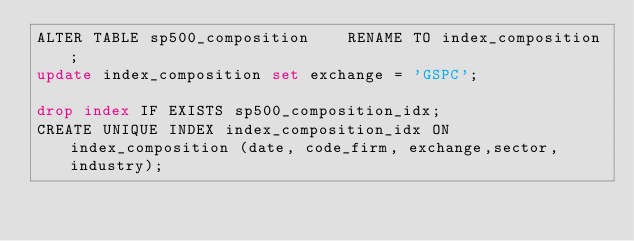<code> <loc_0><loc_0><loc_500><loc_500><_SQL_>ALTER TABLE sp500_composition    RENAME TO index_composition;
update index_composition set exchange = 'GSPC';

drop index IF EXISTS sp500_composition_idx;
CREATE UNIQUE INDEX index_composition_idx ON index_composition (date, code_firm, exchange,sector, industry);
</code> 